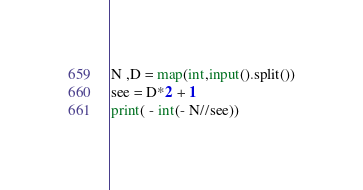<code> <loc_0><loc_0><loc_500><loc_500><_Python_>N ,D = map(int,input().split())
see = D*2 + 1
print( - int(- N//see))</code> 